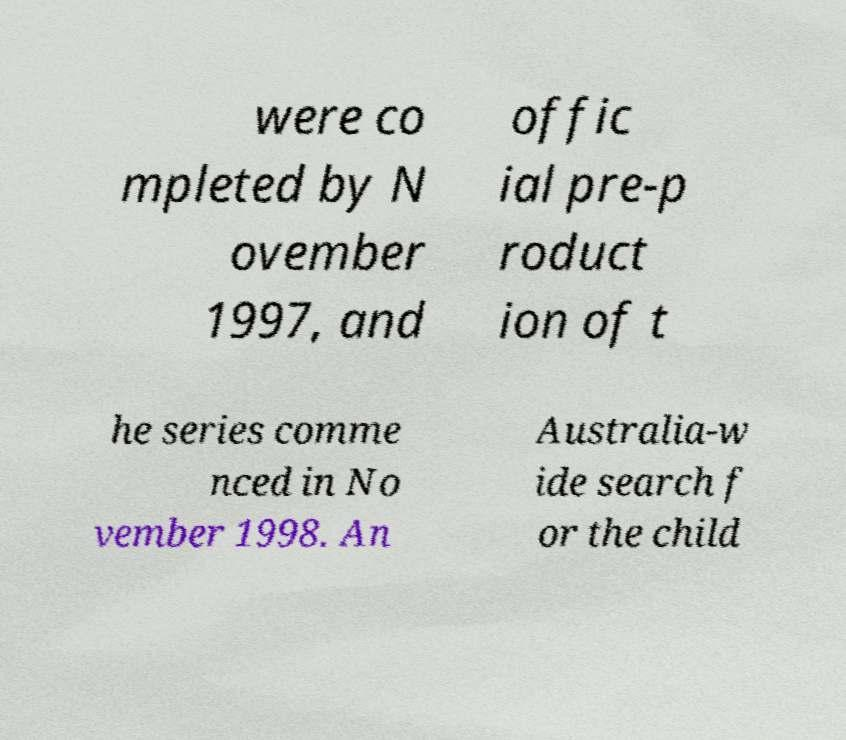Please read and relay the text visible in this image. What does it say? were co mpleted by N ovember 1997, and offic ial pre-p roduct ion of t he series comme nced in No vember 1998. An Australia-w ide search f or the child 